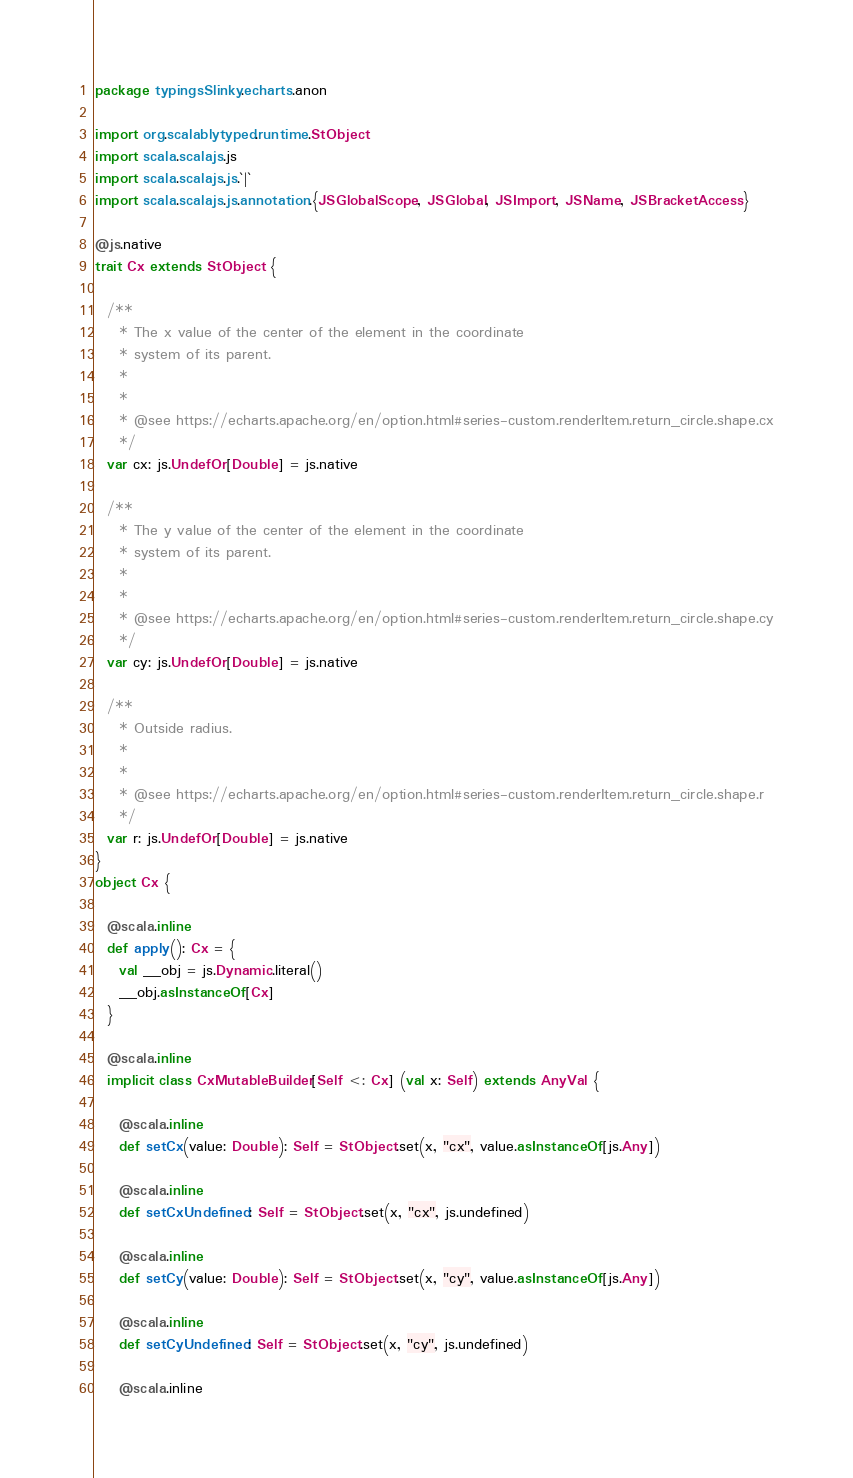Convert code to text. <code><loc_0><loc_0><loc_500><loc_500><_Scala_>package typingsSlinky.echarts.anon

import org.scalablytyped.runtime.StObject
import scala.scalajs.js
import scala.scalajs.js.`|`
import scala.scalajs.js.annotation.{JSGlobalScope, JSGlobal, JSImport, JSName, JSBracketAccess}

@js.native
trait Cx extends StObject {
  
  /**
    * The x value of the center of the element in the coordinate
    * system of its parent.
    *
    *
    * @see https://echarts.apache.org/en/option.html#series-custom.renderItem.return_circle.shape.cx
    */
  var cx: js.UndefOr[Double] = js.native
  
  /**
    * The y value of the center of the element in the coordinate
    * system of its parent.
    *
    *
    * @see https://echarts.apache.org/en/option.html#series-custom.renderItem.return_circle.shape.cy
    */
  var cy: js.UndefOr[Double] = js.native
  
  /**
    * Outside radius.
    *
    *
    * @see https://echarts.apache.org/en/option.html#series-custom.renderItem.return_circle.shape.r
    */
  var r: js.UndefOr[Double] = js.native
}
object Cx {
  
  @scala.inline
  def apply(): Cx = {
    val __obj = js.Dynamic.literal()
    __obj.asInstanceOf[Cx]
  }
  
  @scala.inline
  implicit class CxMutableBuilder[Self <: Cx] (val x: Self) extends AnyVal {
    
    @scala.inline
    def setCx(value: Double): Self = StObject.set(x, "cx", value.asInstanceOf[js.Any])
    
    @scala.inline
    def setCxUndefined: Self = StObject.set(x, "cx", js.undefined)
    
    @scala.inline
    def setCy(value: Double): Self = StObject.set(x, "cy", value.asInstanceOf[js.Any])
    
    @scala.inline
    def setCyUndefined: Self = StObject.set(x, "cy", js.undefined)
    
    @scala.inline</code> 